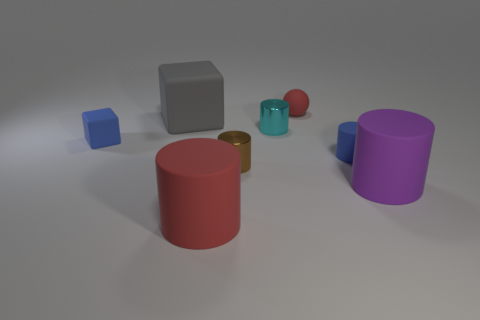Subtract all large red matte cylinders. How many cylinders are left? 4 Add 1 tiny red cubes. How many objects exist? 9 Subtract all gray blocks. How many blocks are left? 1 Subtract all balls. How many objects are left? 7 Subtract 1 gray blocks. How many objects are left? 7 Subtract 4 cylinders. How many cylinders are left? 1 Subtract all yellow cylinders. Subtract all green cubes. How many cylinders are left? 5 Subtract all small blue matte cylinders. Subtract all red cylinders. How many objects are left? 6 Add 4 big gray cubes. How many big gray cubes are left? 5 Add 1 blue rubber cylinders. How many blue rubber cylinders exist? 2 